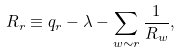Convert formula to latex. <formula><loc_0><loc_0><loc_500><loc_500>R _ { r } \equiv q _ { r } - \lambda - \sum _ { w \sim r } \frac { 1 } { R _ { w } } ,</formula> 